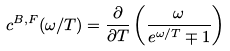<formula> <loc_0><loc_0><loc_500><loc_500>c ^ { B , F } ( \omega / T ) = \frac { \partial } { \partial T } \left ( \frac { \omega } { e ^ { \omega / T } \mp 1 } \right )</formula> 